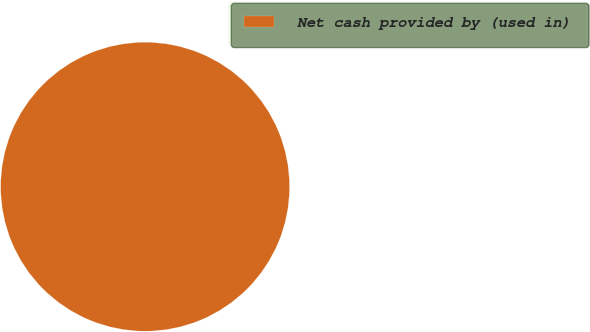Convert chart. <chart><loc_0><loc_0><loc_500><loc_500><pie_chart><fcel>Net cash provided by (used in)<nl><fcel>100.0%<nl></chart> 